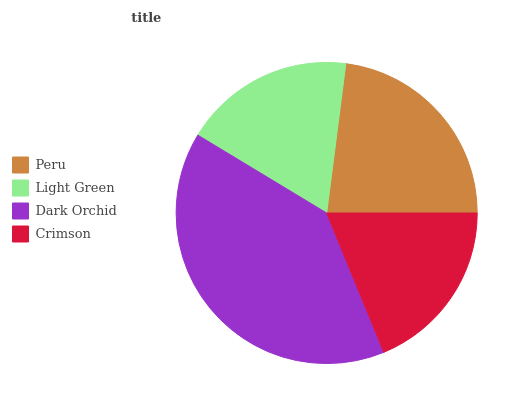Is Light Green the minimum?
Answer yes or no. Yes. Is Dark Orchid the maximum?
Answer yes or no. Yes. Is Dark Orchid the minimum?
Answer yes or no. No. Is Light Green the maximum?
Answer yes or no. No. Is Dark Orchid greater than Light Green?
Answer yes or no. Yes. Is Light Green less than Dark Orchid?
Answer yes or no. Yes. Is Light Green greater than Dark Orchid?
Answer yes or no. No. Is Dark Orchid less than Light Green?
Answer yes or no. No. Is Peru the high median?
Answer yes or no. Yes. Is Crimson the low median?
Answer yes or no. Yes. Is Crimson the high median?
Answer yes or no. No. Is Peru the low median?
Answer yes or no. No. 